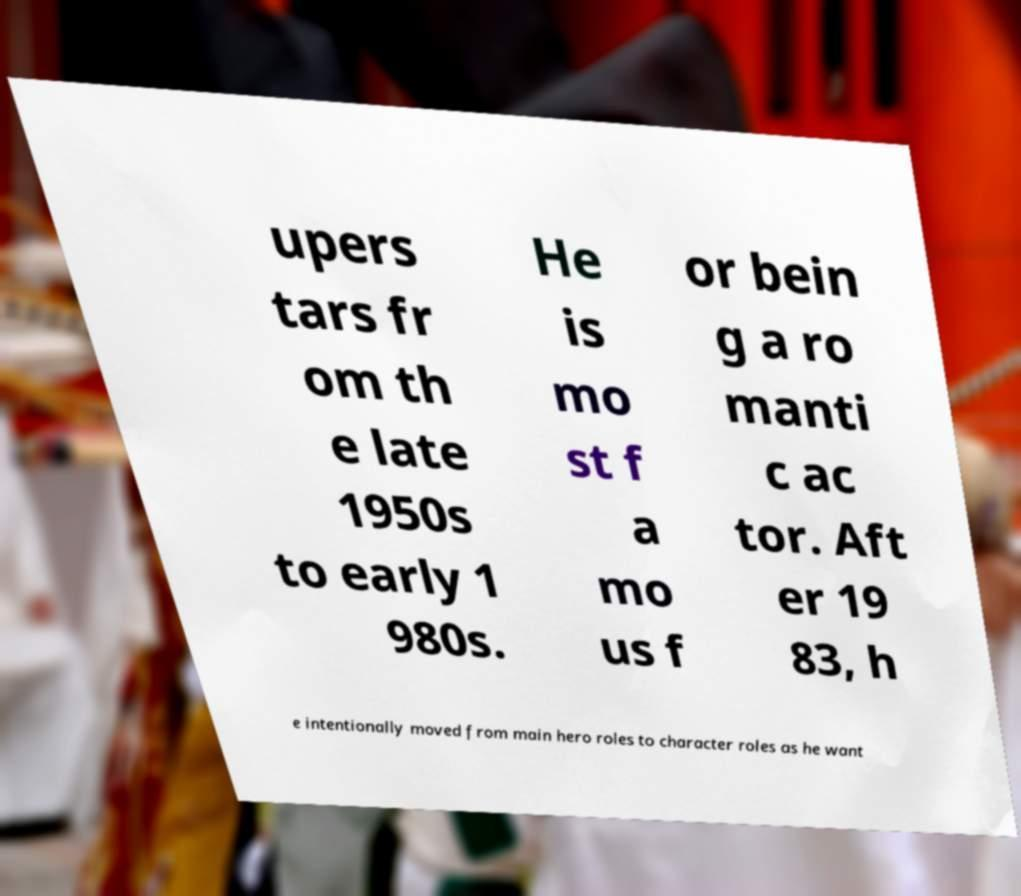Could you assist in decoding the text presented in this image and type it out clearly? upers tars fr om th e late 1950s to early 1 980s. He is mo st f a mo us f or bein g a ro manti c ac tor. Aft er 19 83, h e intentionally moved from main hero roles to character roles as he want 